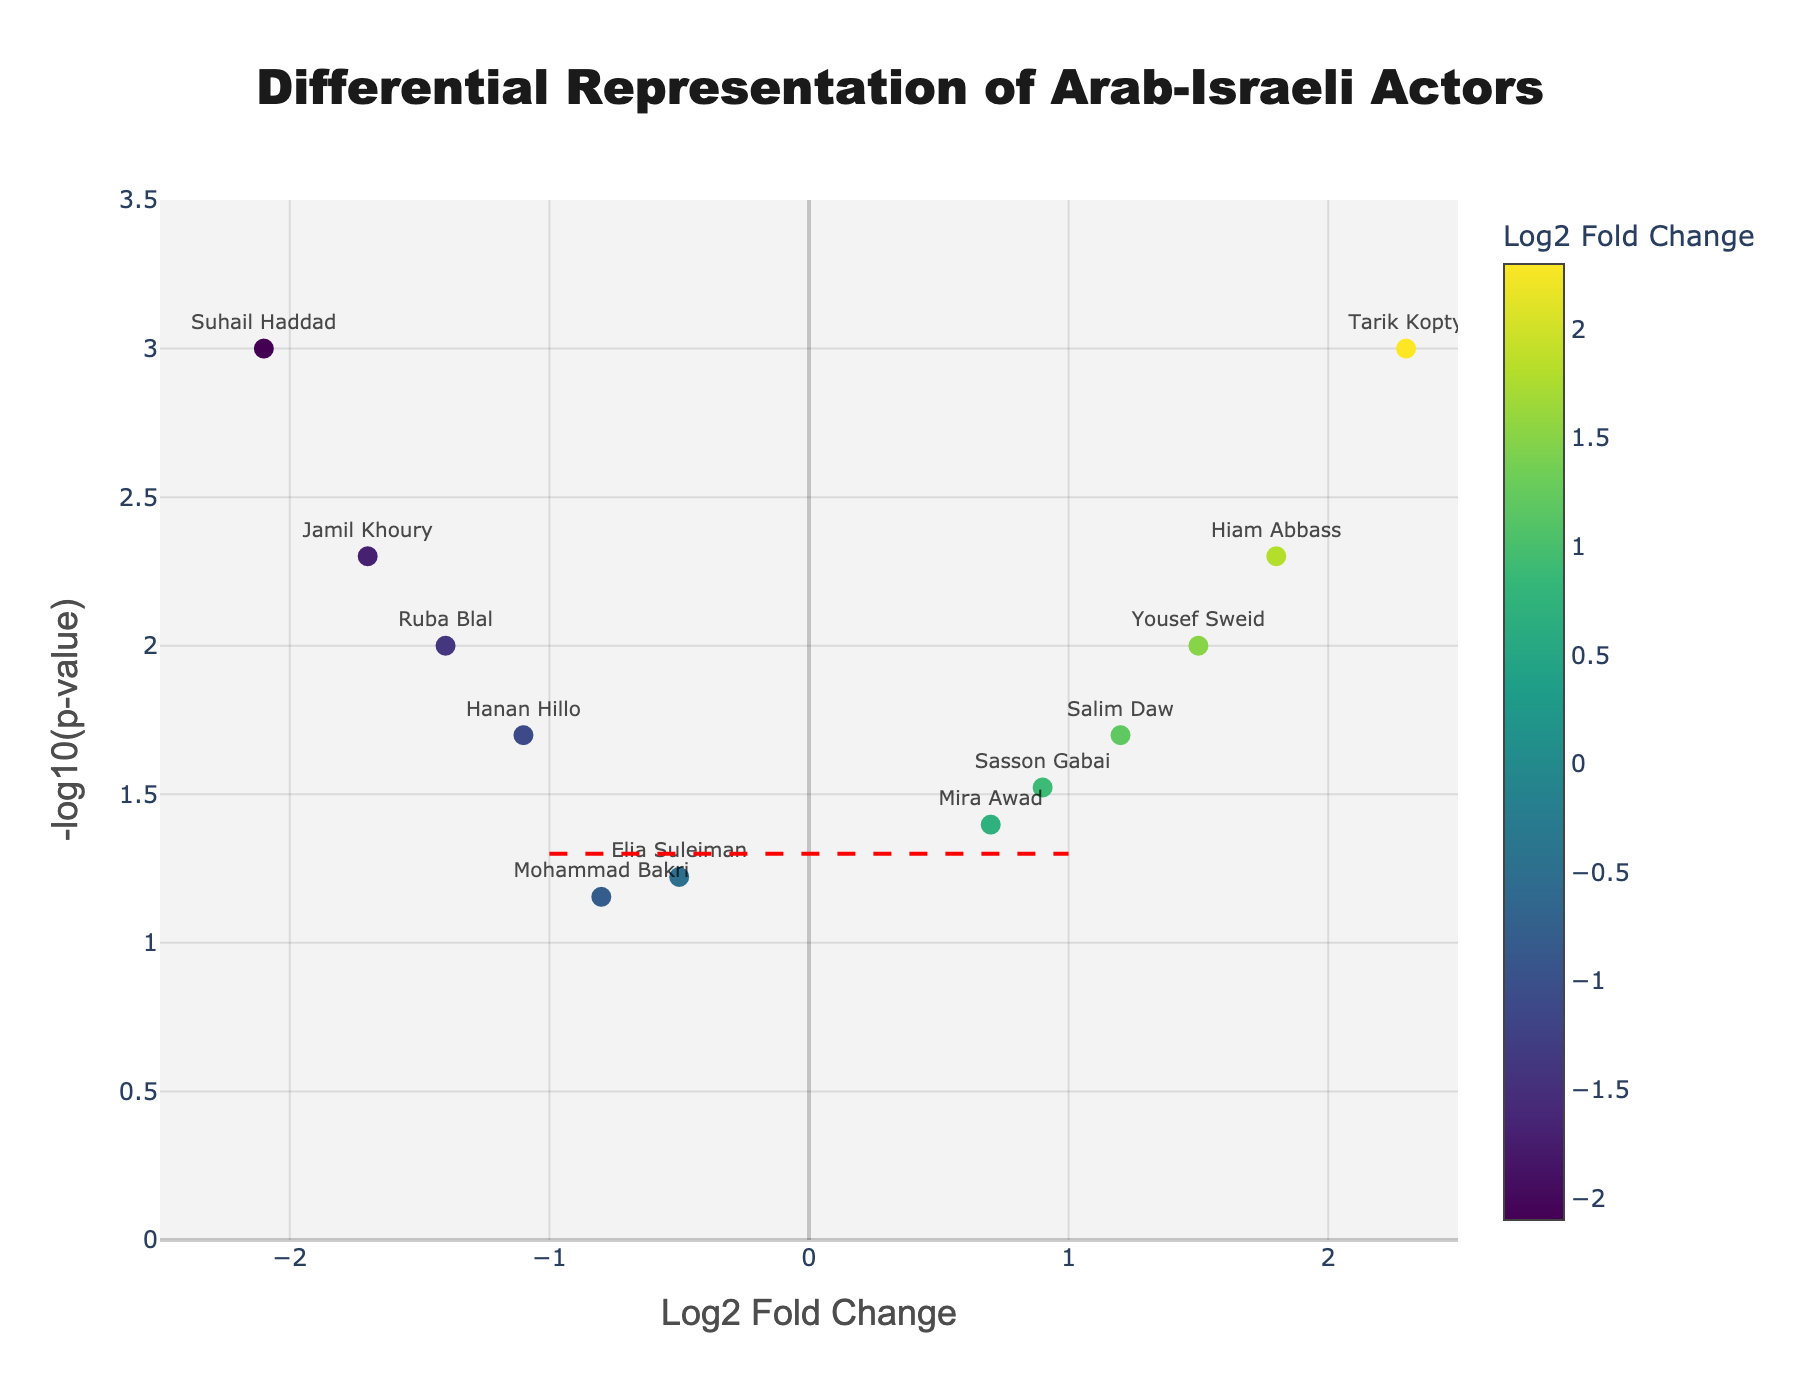What is the title of the plot? The title of the plot is typically shown at the top center and provides a summary of the content of the figure. Here it is: 'Differential Representation of Arab-Israeli Actors'.
Answer: Differential Representation of Arab-Israeli Actors How many actors have a log2 fold change value greater than 1? To find the number of actors with a log2 fold change greater than 1, count the data points to the right of the vertical line at log2 fold change = 1. In this case, we see 3 actors (Tarik Kopty, Hiam Abbass, Yousef Sweid).
Answer: 3 Which actor has the highest log2 fold change? The actor with the highest log2 fold change is represented by the rightmost point on the x-axis. Here, Tarik Kopty has the highest log2 fold change of 2.3.
Answer: Tarik Kopty What is the range of the y-axis? The y-axis measures -log10(p-value), and its range is from 0 to 3.5, as defined in the plot's configuration and displayed on the axis itself.
Answer: 0 to 3.5 Which actor is depicted at the highest point in the plot? The highest point on the y-axis represents the most significant p-value. The actor located at this point is Suhail Haddad with -log10(p-value) greater than 3.
Answer: Suhail Haddad How many actors have a negative log2 fold change? Count the number of data points to the left of the vertical line at log2 fold change = 0. There are 5 actors with negative log2 fold changes: Elia Suleiman, Mohammad Bakri, Hanan Hillo, Ruba Blal, and Jamil Khoury.
Answer: 5 Which actor shows the lowest log2 fold change and what is that value? Identify the actor at the leftmost end of the x-axis. Suhail Haddad has the lowest log2 fold change of -2.1, as shown on the plot.
Answer: Suhail Haddad, -2.1 How many actors have a -log10(p-value) greater than 2? Count the number of data points above the horizontal line at -log10(p-value) = 2. There are 3 actors meeting this criteria: Tarik Kopty, Suhail Haddad, and Jamil Khoury.
Answer: 3 What is the p-value for Hanan Hillo? The plot's hovertext can provide details for specific actors. Hanan Hillo is visible on the plot, and her p-value is 0.02.
Answer: 0.02 How does Tarik Kopty’s log2 fold change compare to Salim Daw’s? Tarik Kopty has a log2 fold change of 2.3, while Salim Daw has a log2 fold change of 1.2. Tarik Kopty's log2 fold change is higher.
Answer: Tarik Kopty’s log2 fold change is higher 